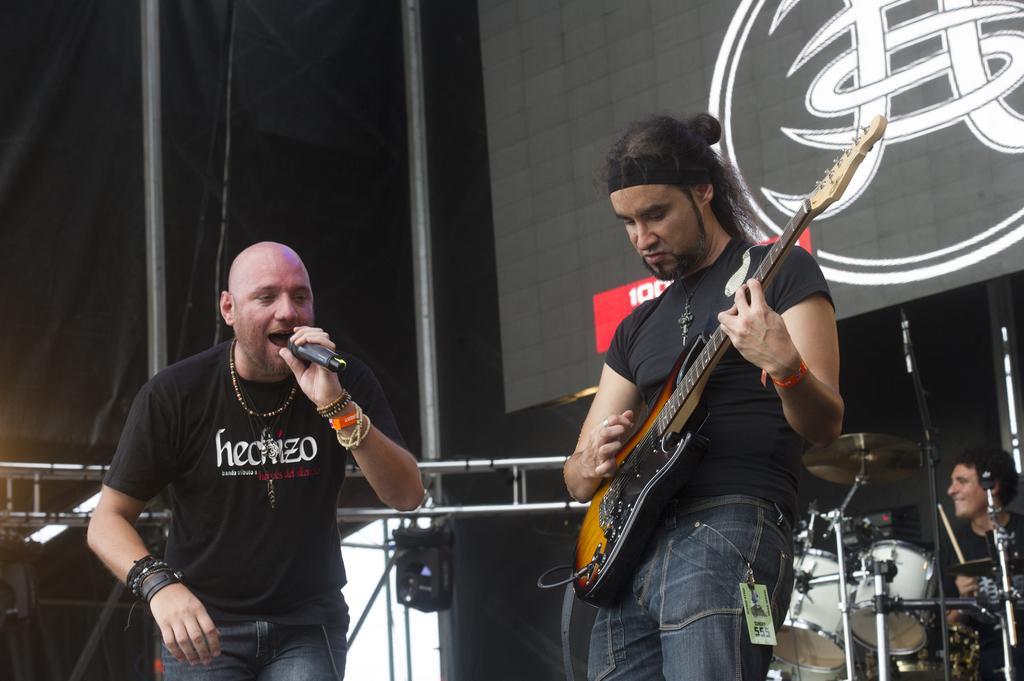Could you give a brief overview of what you see in this image? This is a picture taken on a stage, there are group of people playing a music instrument and singing a song. The man in black t shirt was holding a microphone. Behind these people there is a banner. 